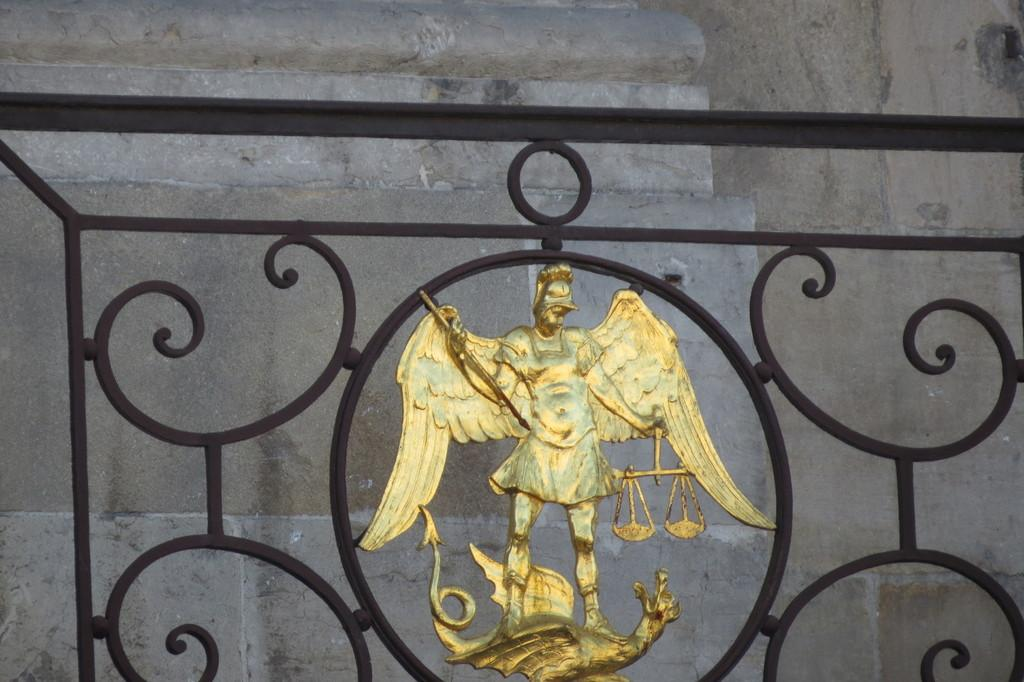What type of object is featured in the image? There is an empire gilt in the image. Can you describe the gate in the image? There is a black color grilled gate in the image. What can be seen in the background of the image? There is a wall visible in the background of the image. What type of humor can be seen in the image? There is no humor present in the image; it features an empire gilt and a black color grilled gate with a wall in the background. What scientific principles are demonstrated in the image? There are no scientific principles demonstrated in the image; it is a static representation of an empire gilt, a black color grilled gate, and a wall. 